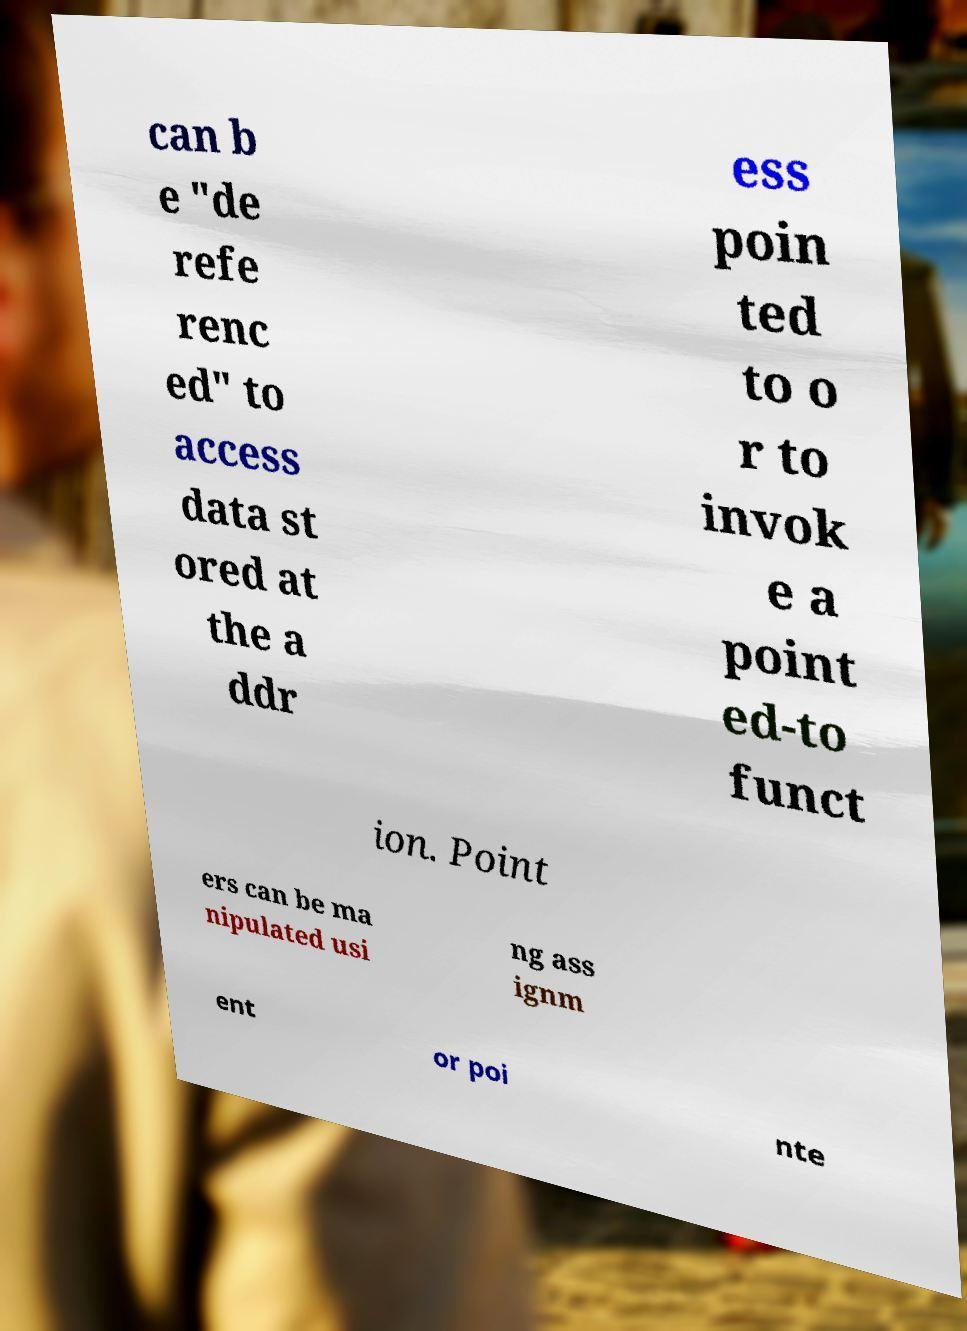Could you extract and type out the text from this image? can b e "de refe renc ed" to access data st ored at the a ddr ess poin ted to o r to invok e a point ed-to funct ion. Point ers can be ma nipulated usi ng ass ignm ent or poi nte 